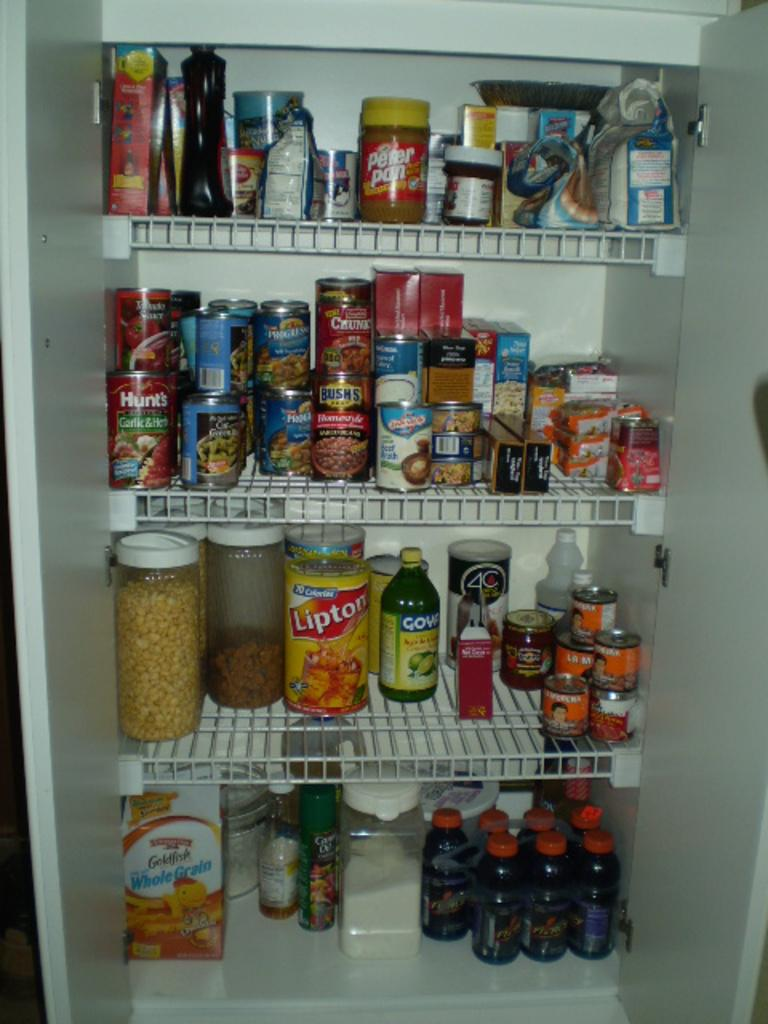<image>
Describe the image concisely. A pantry with four shelves is full of food, including Lipton Iced Tea, baked beans, peanut butter and many other items. 